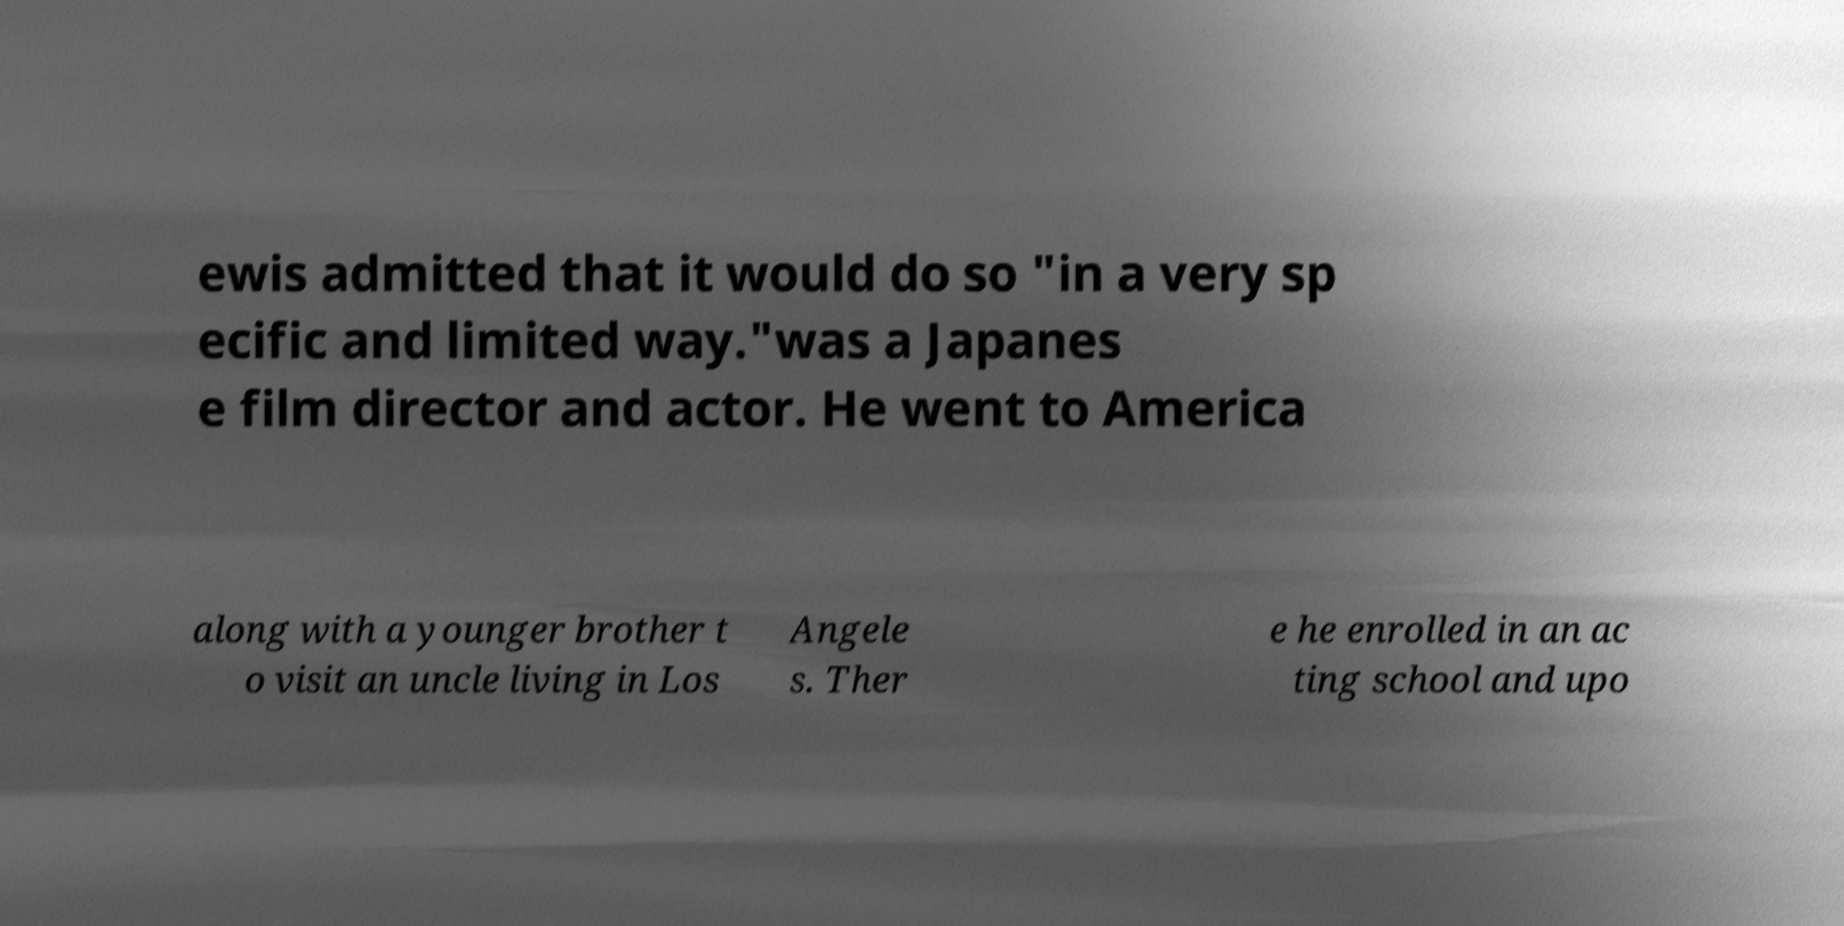For documentation purposes, I need the text within this image transcribed. Could you provide that? ewis admitted that it would do so "in a very sp ecific and limited way."was a Japanes e film director and actor. He went to America along with a younger brother t o visit an uncle living in Los Angele s. Ther e he enrolled in an ac ting school and upo 